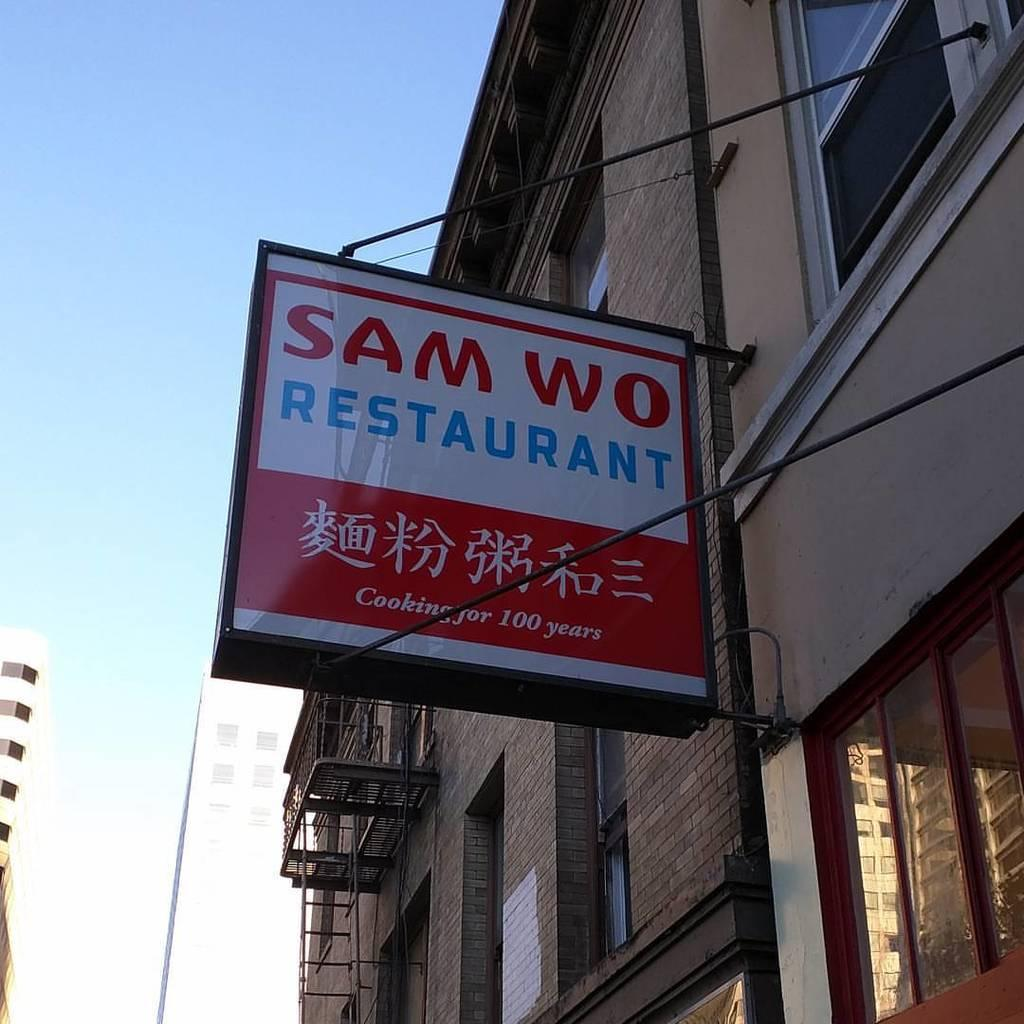What is the main subject of the image? The main subject of the image is a restaurant banner. Can you describe the surrounding environment in the image? There are multiple buildings visible in the image. What type of form is being filled out by the drain in the image? There is no form or drain present in the image; it only features a restaurant banner and multiple buildings. 